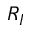<formula> <loc_0><loc_0><loc_500><loc_500>R _ { I }</formula> 